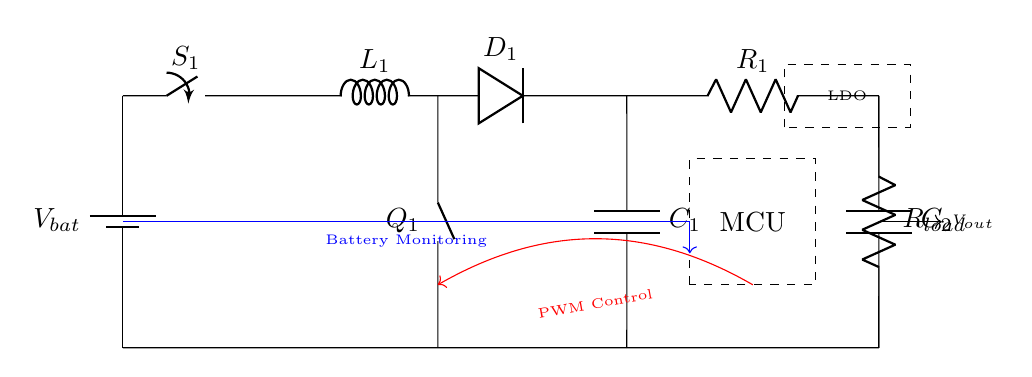What is the main function of the boost converter in this circuit? The boost converter increases the voltage from the battery to the level required by the microcontroller and load. This is necessary because the load may require a higher voltage than what the battery provides.
Answer: Increases voltage What component is responsible for regulating the output voltage? The low dropout regulator (LDO) is placed in the path of the output voltage and ensures that the voltage supplied to the load is stable and within the desired range, even when the input voltage fluctuates.
Answer: Low dropout regulator What is the purpose of the inductor in the boost converter? The inductor stores energy when current flows through it and releases it when the current decreases, enabling the boost converter to step up the voltage effectively. It is essential for the operation of the boost converter's energy transfer process.
Answer: Energy storage How does the battery monitoring affect the circuit operation? The battery monitoring system provides feedback to manage the battery’s state. It ensures that the microcontroller receives correct data about the battery's voltage level, which is crucial for controlling power usage and preventing over-discharge.
Answer: Manages battery state What is the role of the PWM control in this circuit? PWM control adjusts the amount of energy delivered to the load by varying the duty cycle of the power switch. This regulation optimizes power consumption, ultimately extending battery life in portable devices.
Answer: Regulates energy delivery How does the feedback loop enhance efficiency in this circuit? The feedback loop connects the microcontroller and the boost converter, allowing the circuit to dynamically adjust the operation of the boost converter based on the load requirements. This optimizes energy use and improves overall efficiency.
Answer: Optimizes energy use 